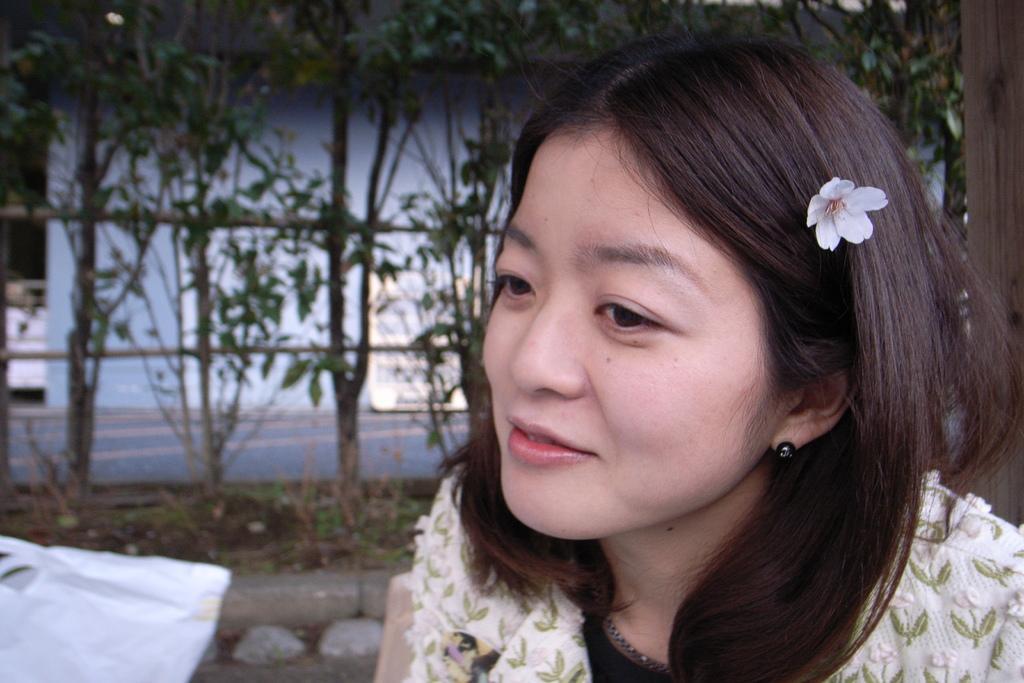In one or two sentences, can you explain what this image depicts? In this image I can see a woman, there is a flower in her hair. There are plants at the back. 